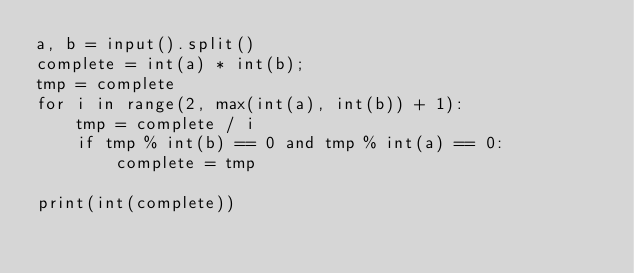Convert code to text. <code><loc_0><loc_0><loc_500><loc_500><_Python_>a, b = input().split()
complete = int(a) * int(b);
tmp = complete
for i in range(2, max(int(a), int(b)) + 1):
    tmp = complete / i
    if tmp % int(b) == 0 and tmp % int(a) == 0:
        complete = tmp

print(int(complete))

</code> 